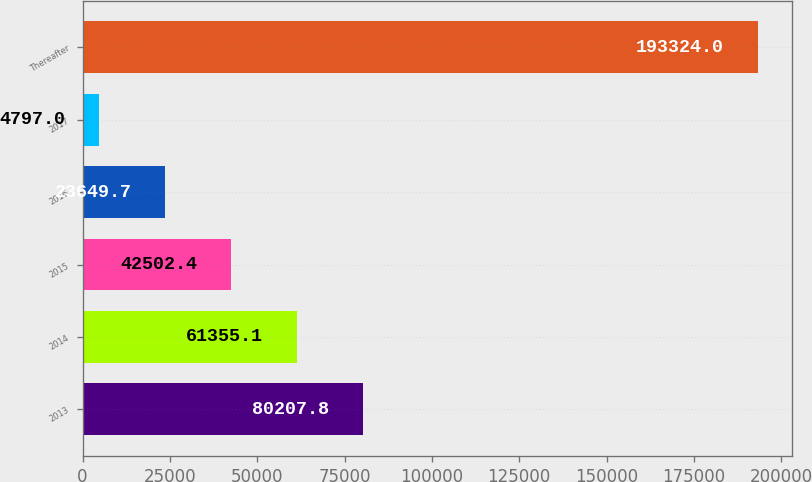<chart> <loc_0><loc_0><loc_500><loc_500><bar_chart><fcel>2013<fcel>2014<fcel>2015<fcel>2016<fcel>2017<fcel>Thereafter<nl><fcel>80207.8<fcel>61355.1<fcel>42502.4<fcel>23649.7<fcel>4797<fcel>193324<nl></chart> 